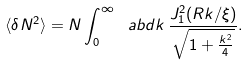Convert formula to latex. <formula><loc_0><loc_0><loc_500><loc_500>\langle \delta N ^ { 2 } \rangle = N \int _ { 0 } ^ { \infty } \ a b d k \, \frac { J _ { 1 } ^ { 2 } ( R k / \xi ) } { \sqrt { 1 + \frac { k ^ { 2 } } { 4 } } } .</formula> 